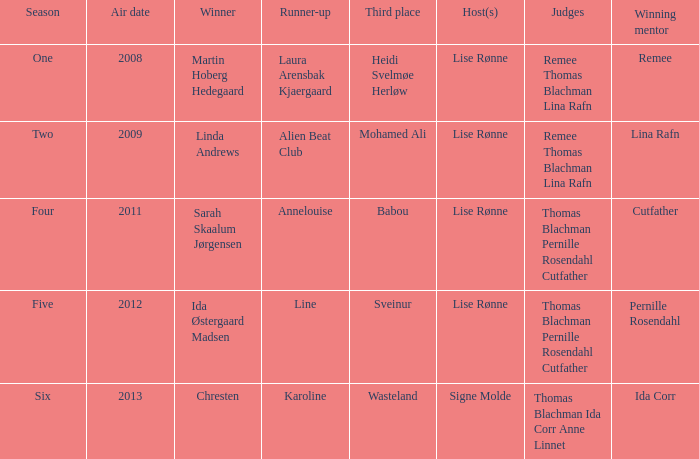Who was the successful guide in season two? Lina Rafn. 